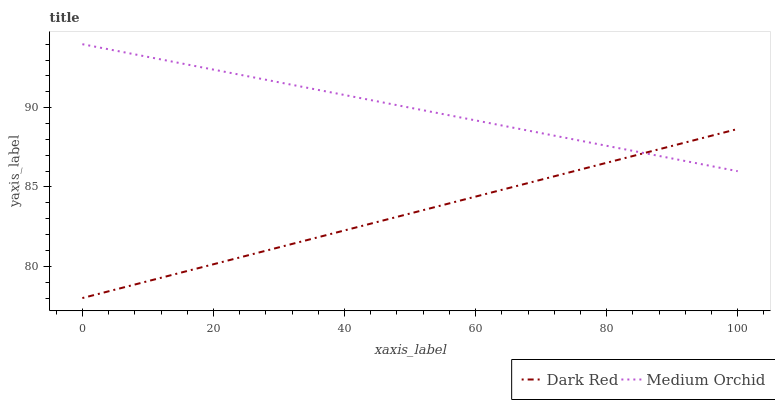Does Dark Red have the minimum area under the curve?
Answer yes or no. Yes. Does Medium Orchid have the maximum area under the curve?
Answer yes or no. Yes. Does Medium Orchid have the minimum area under the curve?
Answer yes or no. No. Is Medium Orchid the smoothest?
Answer yes or no. Yes. Is Dark Red the roughest?
Answer yes or no. Yes. Is Medium Orchid the roughest?
Answer yes or no. No. Does Medium Orchid have the lowest value?
Answer yes or no. No. Does Medium Orchid have the highest value?
Answer yes or no. Yes. Does Medium Orchid intersect Dark Red?
Answer yes or no. Yes. Is Medium Orchid less than Dark Red?
Answer yes or no. No. Is Medium Orchid greater than Dark Red?
Answer yes or no. No. 